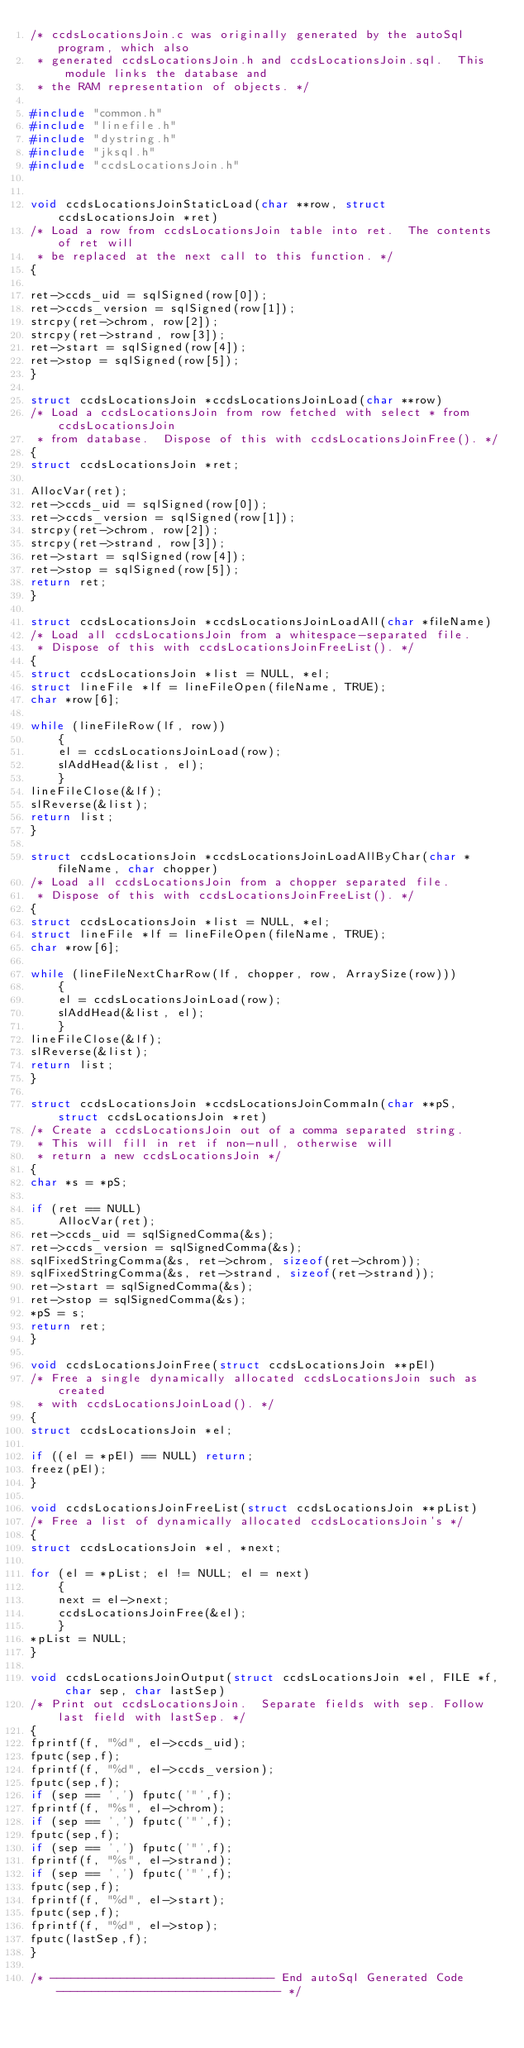<code> <loc_0><loc_0><loc_500><loc_500><_C_>/* ccdsLocationsJoin.c was originally generated by the autoSql program, which also 
 * generated ccdsLocationsJoin.h and ccdsLocationsJoin.sql.  This module links the database and
 * the RAM representation of objects. */

#include "common.h"
#include "linefile.h"
#include "dystring.h"
#include "jksql.h"
#include "ccdsLocationsJoin.h"


void ccdsLocationsJoinStaticLoad(char **row, struct ccdsLocationsJoin *ret)
/* Load a row from ccdsLocationsJoin table into ret.  The contents of ret will
 * be replaced at the next call to this function. */
{

ret->ccds_uid = sqlSigned(row[0]);
ret->ccds_version = sqlSigned(row[1]);
strcpy(ret->chrom, row[2]);
strcpy(ret->strand, row[3]);
ret->start = sqlSigned(row[4]);
ret->stop = sqlSigned(row[5]);
}

struct ccdsLocationsJoin *ccdsLocationsJoinLoad(char **row)
/* Load a ccdsLocationsJoin from row fetched with select * from ccdsLocationsJoin
 * from database.  Dispose of this with ccdsLocationsJoinFree(). */
{
struct ccdsLocationsJoin *ret;

AllocVar(ret);
ret->ccds_uid = sqlSigned(row[0]);
ret->ccds_version = sqlSigned(row[1]);
strcpy(ret->chrom, row[2]);
strcpy(ret->strand, row[3]);
ret->start = sqlSigned(row[4]);
ret->stop = sqlSigned(row[5]);
return ret;
}

struct ccdsLocationsJoin *ccdsLocationsJoinLoadAll(char *fileName) 
/* Load all ccdsLocationsJoin from a whitespace-separated file.
 * Dispose of this with ccdsLocationsJoinFreeList(). */
{
struct ccdsLocationsJoin *list = NULL, *el;
struct lineFile *lf = lineFileOpen(fileName, TRUE);
char *row[6];

while (lineFileRow(lf, row))
    {
    el = ccdsLocationsJoinLoad(row);
    slAddHead(&list, el);
    }
lineFileClose(&lf);
slReverse(&list);
return list;
}

struct ccdsLocationsJoin *ccdsLocationsJoinLoadAllByChar(char *fileName, char chopper) 
/* Load all ccdsLocationsJoin from a chopper separated file.
 * Dispose of this with ccdsLocationsJoinFreeList(). */
{
struct ccdsLocationsJoin *list = NULL, *el;
struct lineFile *lf = lineFileOpen(fileName, TRUE);
char *row[6];

while (lineFileNextCharRow(lf, chopper, row, ArraySize(row)))
    {
    el = ccdsLocationsJoinLoad(row);
    slAddHead(&list, el);
    }
lineFileClose(&lf);
slReverse(&list);
return list;
}

struct ccdsLocationsJoin *ccdsLocationsJoinCommaIn(char **pS, struct ccdsLocationsJoin *ret)
/* Create a ccdsLocationsJoin out of a comma separated string. 
 * This will fill in ret if non-null, otherwise will
 * return a new ccdsLocationsJoin */
{
char *s = *pS;

if (ret == NULL)
    AllocVar(ret);
ret->ccds_uid = sqlSignedComma(&s);
ret->ccds_version = sqlSignedComma(&s);
sqlFixedStringComma(&s, ret->chrom, sizeof(ret->chrom));
sqlFixedStringComma(&s, ret->strand, sizeof(ret->strand));
ret->start = sqlSignedComma(&s);
ret->stop = sqlSignedComma(&s);
*pS = s;
return ret;
}

void ccdsLocationsJoinFree(struct ccdsLocationsJoin **pEl)
/* Free a single dynamically allocated ccdsLocationsJoin such as created
 * with ccdsLocationsJoinLoad(). */
{
struct ccdsLocationsJoin *el;

if ((el = *pEl) == NULL) return;
freez(pEl);
}

void ccdsLocationsJoinFreeList(struct ccdsLocationsJoin **pList)
/* Free a list of dynamically allocated ccdsLocationsJoin's */
{
struct ccdsLocationsJoin *el, *next;

for (el = *pList; el != NULL; el = next)
    {
    next = el->next;
    ccdsLocationsJoinFree(&el);
    }
*pList = NULL;
}

void ccdsLocationsJoinOutput(struct ccdsLocationsJoin *el, FILE *f, char sep, char lastSep) 
/* Print out ccdsLocationsJoin.  Separate fields with sep. Follow last field with lastSep. */
{
fprintf(f, "%d", el->ccds_uid);
fputc(sep,f);
fprintf(f, "%d", el->ccds_version);
fputc(sep,f);
if (sep == ',') fputc('"',f);
fprintf(f, "%s", el->chrom);
if (sep == ',') fputc('"',f);
fputc(sep,f);
if (sep == ',') fputc('"',f);
fprintf(f, "%s", el->strand);
if (sep == ',') fputc('"',f);
fputc(sep,f);
fprintf(f, "%d", el->start);
fputc(sep,f);
fprintf(f, "%d", el->stop);
fputc(lastSep,f);
}

/* -------------------------------- End autoSql Generated Code -------------------------------- */

</code> 